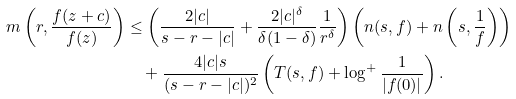<formula> <loc_0><loc_0><loc_500><loc_500>m \left ( r , \frac { f ( z + c ) } { f ( z ) } \right ) & \leq \left ( \frac { 2 | c | } { s - r - | c | } + \frac { 2 | c | ^ { \delta } } { \delta ( 1 - \delta ) } \frac { 1 } { r ^ { \delta } } \right ) \left ( n ( s , f ) + n \left ( s , \frac { 1 } { f } \right ) \right ) \\ & \quad + \frac { 4 | c | s } { ( s - r - | c | ) ^ { 2 } } \left ( T ( s , f ) + \log ^ { + } \frac { 1 } { | f ( 0 ) | } \right ) .</formula> 